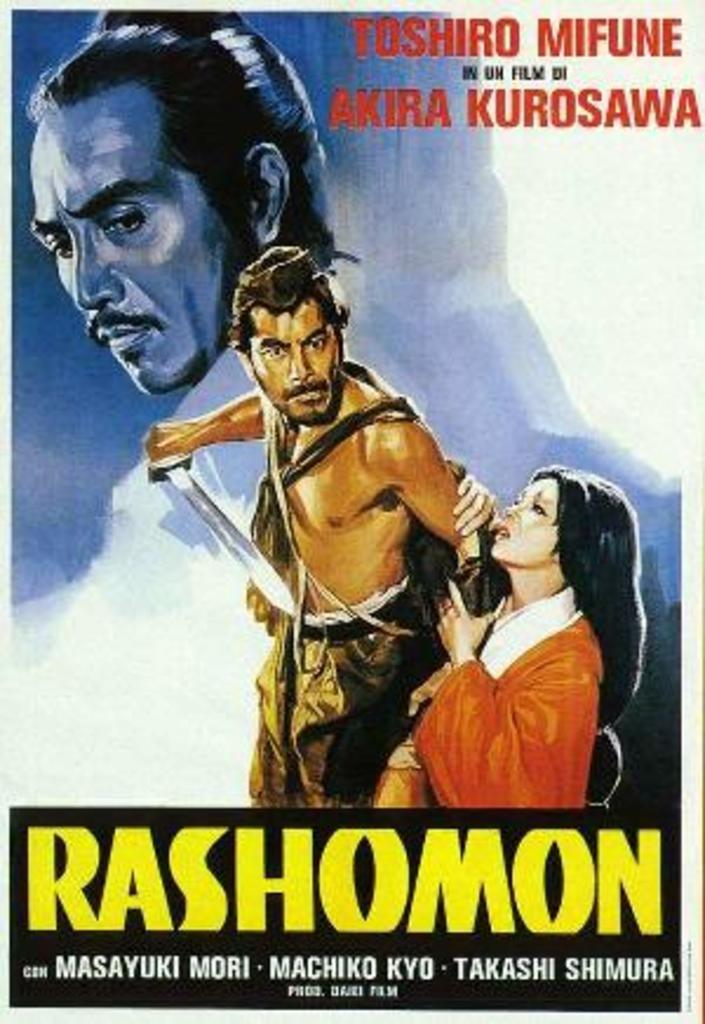<image>
Share a concise interpretation of the image provided. A book called Rashomon by Masayuki Mori, Machiko Kyo, and Takashi Shimura with people on the front cover. 